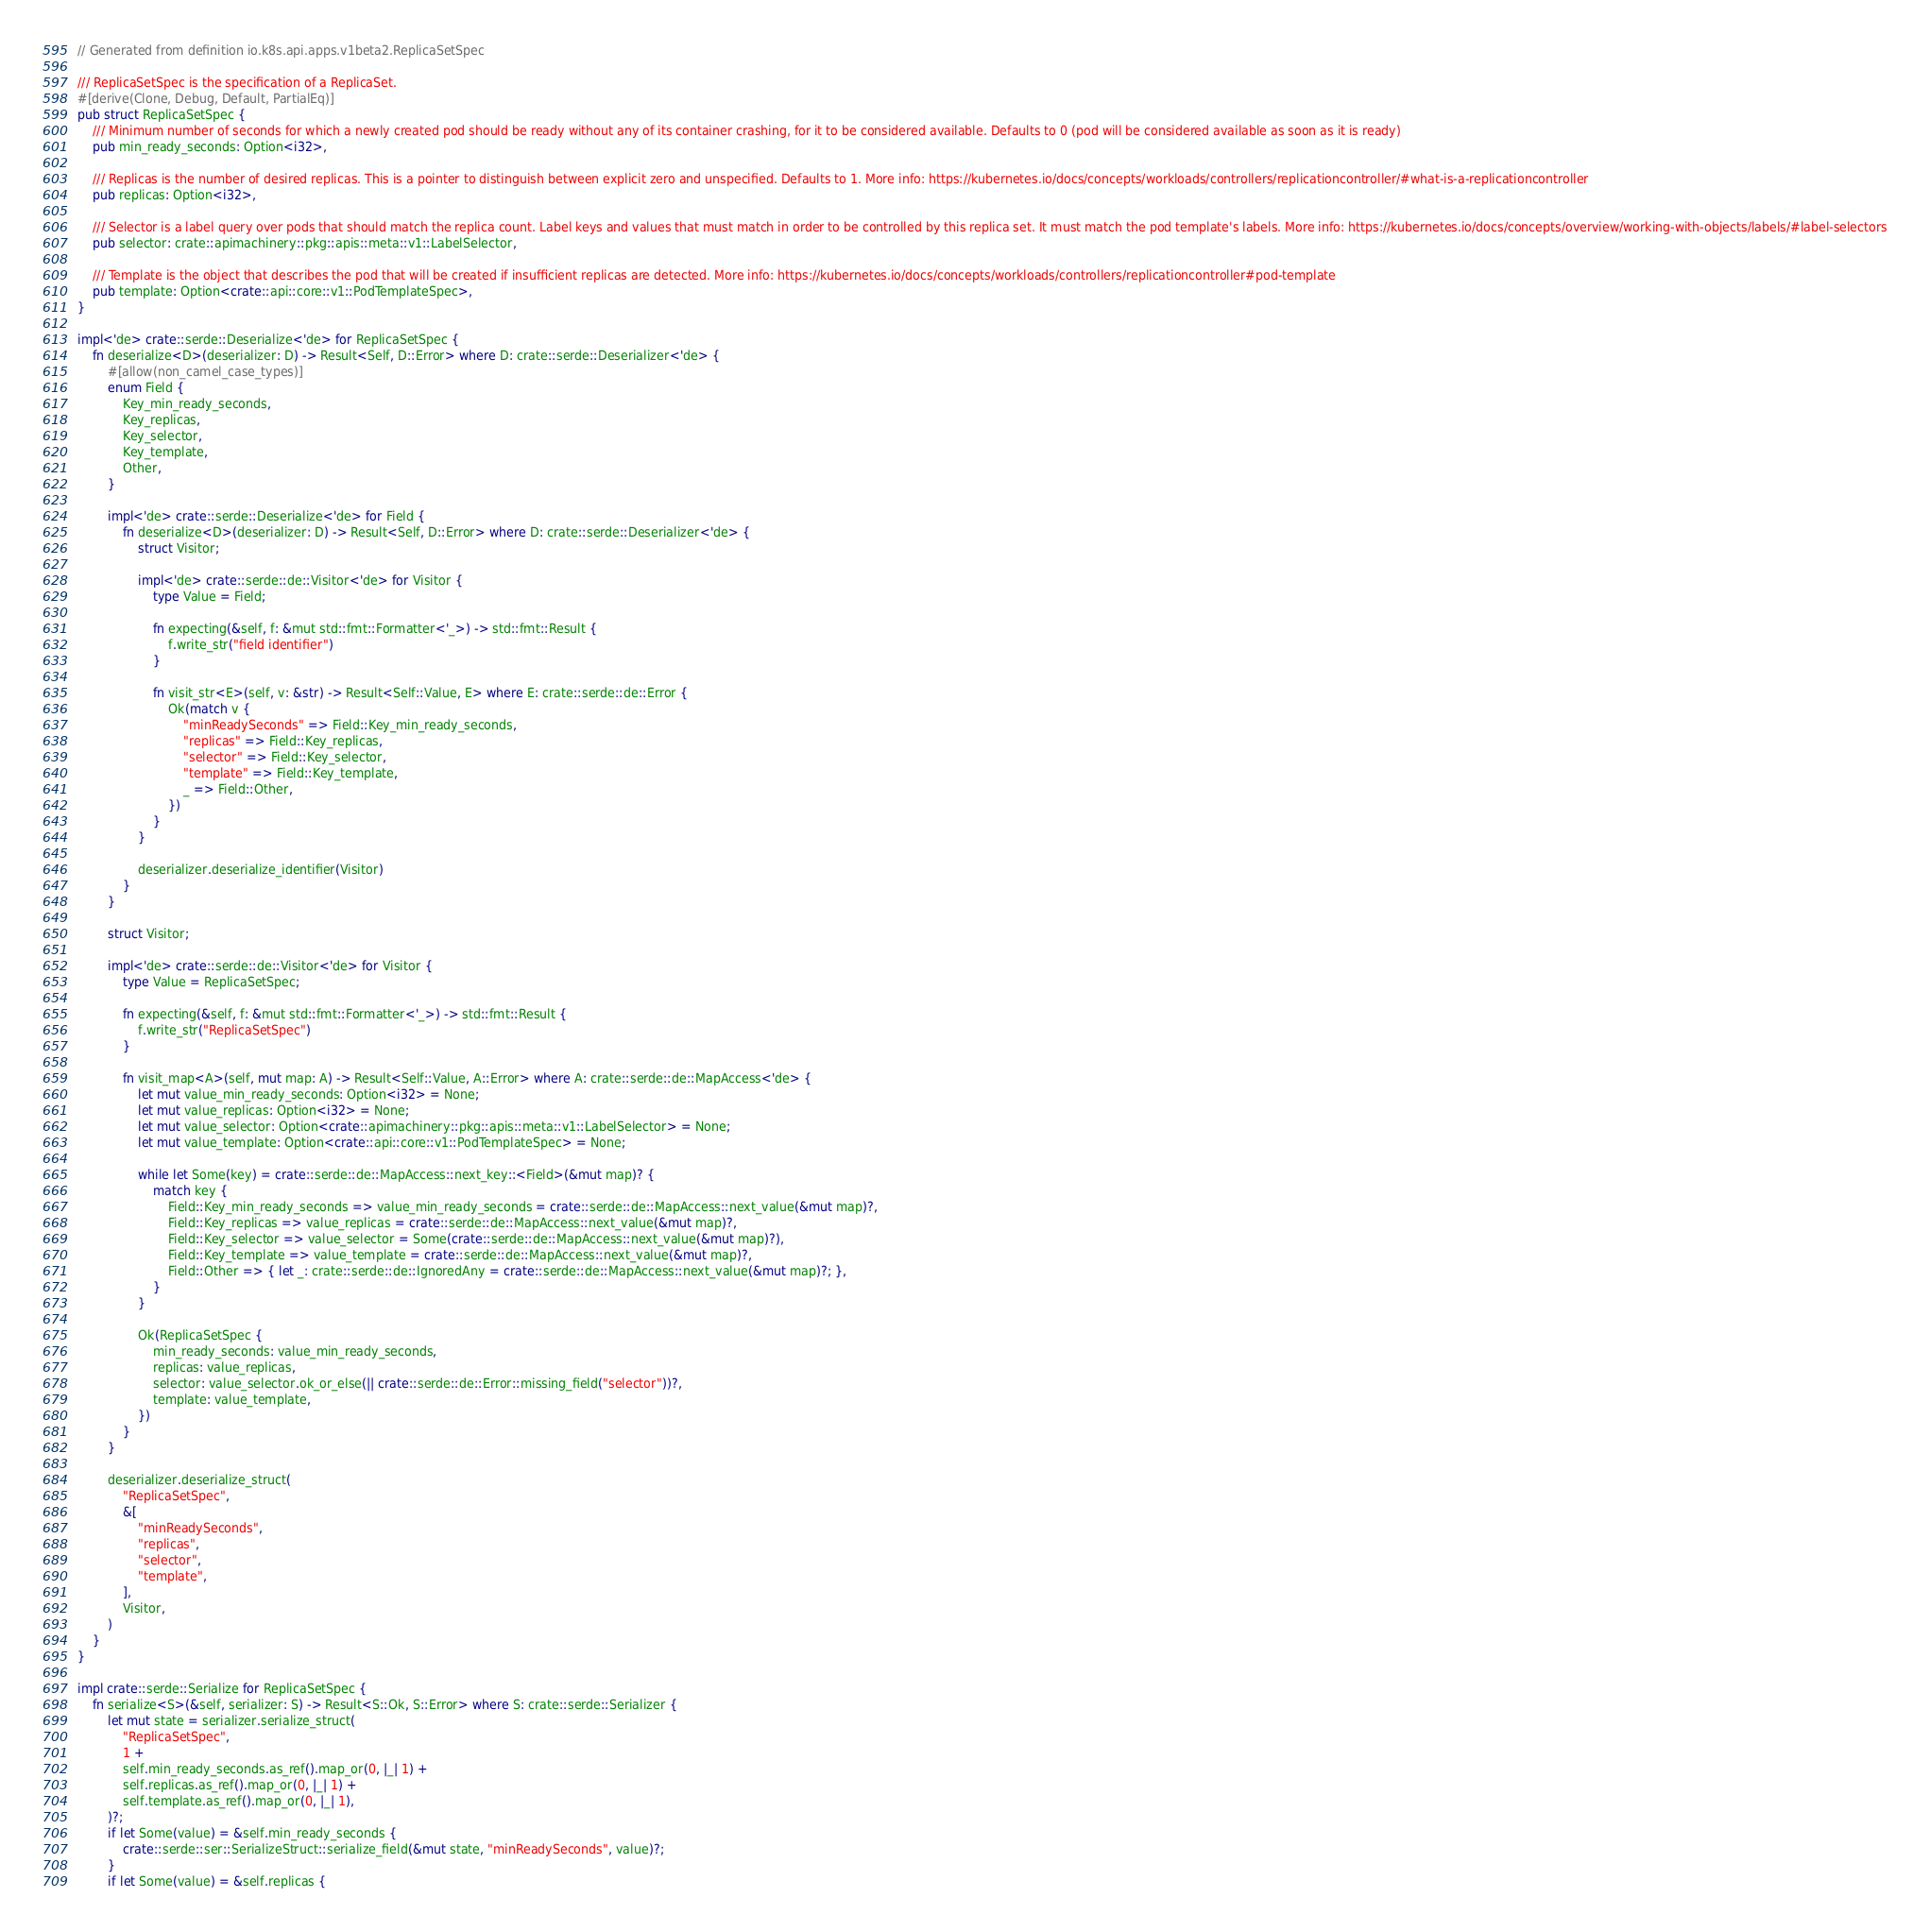<code> <loc_0><loc_0><loc_500><loc_500><_Rust_>// Generated from definition io.k8s.api.apps.v1beta2.ReplicaSetSpec

/// ReplicaSetSpec is the specification of a ReplicaSet.
#[derive(Clone, Debug, Default, PartialEq)]
pub struct ReplicaSetSpec {
    /// Minimum number of seconds for which a newly created pod should be ready without any of its container crashing, for it to be considered available. Defaults to 0 (pod will be considered available as soon as it is ready)
    pub min_ready_seconds: Option<i32>,

    /// Replicas is the number of desired replicas. This is a pointer to distinguish between explicit zero and unspecified. Defaults to 1. More info: https://kubernetes.io/docs/concepts/workloads/controllers/replicationcontroller/#what-is-a-replicationcontroller
    pub replicas: Option<i32>,

    /// Selector is a label query over pods that should match the replica count. Label keys and values that must match in order to be controlled by this replica set. It must match the pod template's labels. More info: https://kubernetes.io/docs/concepts/overview/working-with-objects/labels/#label-selectors
    pub selector: crate::apimachinery::pkg::apis::meta::v1::LabelSelector,

    /// Template is the object that describes the pod that will be created if insufficient replicas are detected. More info: https://kubernetes.io/docs/concepts/workloads/controllers/replicationcontroller#pod-template
    pub template: Option<crate::api::core::v1::PodTemplateSpec>,
}

impl<'de> crate::serde::Deserialize<'de> for ReplicaSetSpec {
    fn deserialize<D>(deserializer: D) -> Result<Self, D::Error> where D: crate::serde::Deserializer<'de> {
        #[allow(non_camel_case_types)]
        enum Field {
            Key_min_ready_seconds,
            Key_replicas,
            Key_selector,
            Key_template,
            Other,
        }

        impl<'de> crate::serde::Deserialize<'de> for Field {
            fn deserialize<D>(deserializer: D) -> Result<Self, D::Error> where D: crate::serde::Deserializer<'de> {
                struct Visitor;

                impl<'de> crate::serde::de::Visitor<'de> for Visitor {
                    type Value = Field;

                    fn expecting(&self, f: &mut std::fmt::Formatter<'_>) -> std::fmt::Result {
                        f.write_str("field identifier")
                    }

                    fn visit_str<E>(self, v: &str) -> Result<Self::Value, E> where E: crate::serde::de::Error {
                        Ok(match v {
                            "minReadySeconds" => Field::Key_min_ready_seconds,
                            "replicas" => Field::Key_replicas,
                            "selector" => Field::Key_selector,
                            "template" => Field::Key_template,
                            _ => Field::Other,
                        })
                    }
                }

                deserializer.deserialize_identifier(Visitor)
            }
        }

        struct Visitor;

        impl<'de> crate::serde::de::Visitor<'de> for Visitor {
            type Value = ReplicaSetSpec;

            fn expecting(&self, f: &mut std::fmt::Formatter<'_>) -> std::fmt::Result {
                f.write_str("ReplicaSetSpec")
            }

            fn visit_map<A>(self, mut map: A) -> Result<Self::Value, A::Error> where A: crate::serde::de::MapAccess<'de> {
                let mut value_min_ready_seconds: Option<i32> = None;
                let mut value_replicas: Option<i32> = None;
                let mut value_selector: Option<crate::apimachinery::pkg::apis::meta::v1::LabelSelector> = None;
                let mut value_template: Option<crate::api::core::v1::PodTemplateSpec> = None;

                while let Some(key) = crate::serde::de::MapAccess::next_key::<Field>(&mut map)? {
                    match key {
                        Field::Key_min_ready_seconds => value_min_ready_seconds = crate::serde::de::MapAccess::next_value(&mut map)?,
                        Field::Key_replicas => value_replicas = crate::serde::de::MapAccess::next_value(&mut map)?,
                        Field::Key_selector => value_selector = Some(crate::serde::de::MapAccess::next_value(&mut map)?),
                        Field::Key_template => value_template = crate::serde::de::MapAccess::next_value(&mut map)?,
                        Field::Other => { let _: crate::serde::de::IgnoredAny = crate::serde::de::MapAccess::next_value(&mut map)?; },
                    }
                }

                Ok(ReplicaSetSpec {
                    min_ready_seconds: value_min_ready_seconds,
                    replicas: value_replicas,
                    selector: value_selector.ok_or_else(|| crate::serde::de::Error::missing_field("selector"))?,
                    template: value_template,
                })
            }
        }

        deserializer.deserialize_struct(
            "ReplicaSetSpec",
            &[
                "minReadySeconds",
                "replicas",
                "selector",
                "template",
            ],
            Visitor,
        )
    }
}

impl crate::serde::Serialize for ReplicaSetSpec {
    fn serialize<S>(&self, serializer: S) -> Result<S::Ok, S::Error> where S: crate::serde::Serializer {
        let mut state = serializer.serialize_struct(
            "ReplicaSetSpec",
            1 +
            self.min_ready_seconds.as_ref().map_or(0, |_| 1) +
            self.replicas.as_ref().map_or(0, |_| 1) +
            self.template.as_ref().map_or(0, |_| 1),
        )?;
        if let Some(value) = &self.min_ready_seconds {
            crate::serde::ser::SerializeStruct::serialize_field(&mut state, "minReadySeconds", value)?;
        }
        if let Some(value) = &self.replicas {</code> 